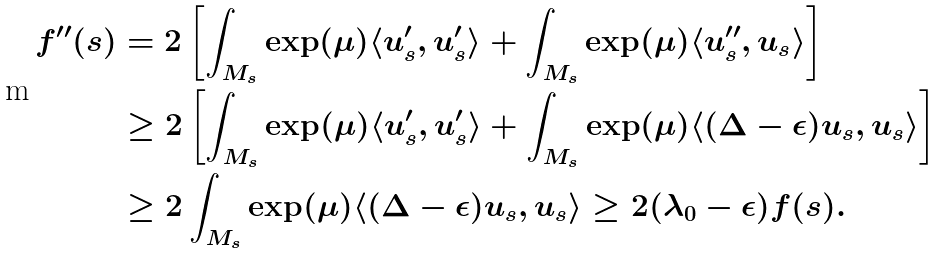Convert formula to latex. <formula><loc_0><loc_0><loc_500><loc_500>\quad f ^ { \prime \prime } ( s ) & = 2 \left [ \int _ { M _ { s } } \exp ( \mu ) \langle u _ { s } ^ { \prime } , u _ { s } ^ { \prime } \rangle + \int _ { M _ { s } } \exp ( \mu ) \langle u _ { s } ^ { \prime \prime } , u _ { s } \rangle \right ] \\ & \geq 2 \left [ \int _ { M _ { s } } \exp ( \mu ) \langle u _ { s } ^ { \prime } , u _ { s } ^ { \prime } \rangle + \int _ { M _ { s } } \exp ( \mu ) \langle ( \Delta - \epsilon ) u _ { s } , u _ { s } \rangle \right ] \\ & \geq 2 \int _ { M _ { s } } \exp ( \mu ) \langle ( \Delta - \epsilon ) u _ { s } , u _ { s } \rangle \geq 2 ( \lambda _ { 0 } - \epsilon ) f ( s ) .</formula> 